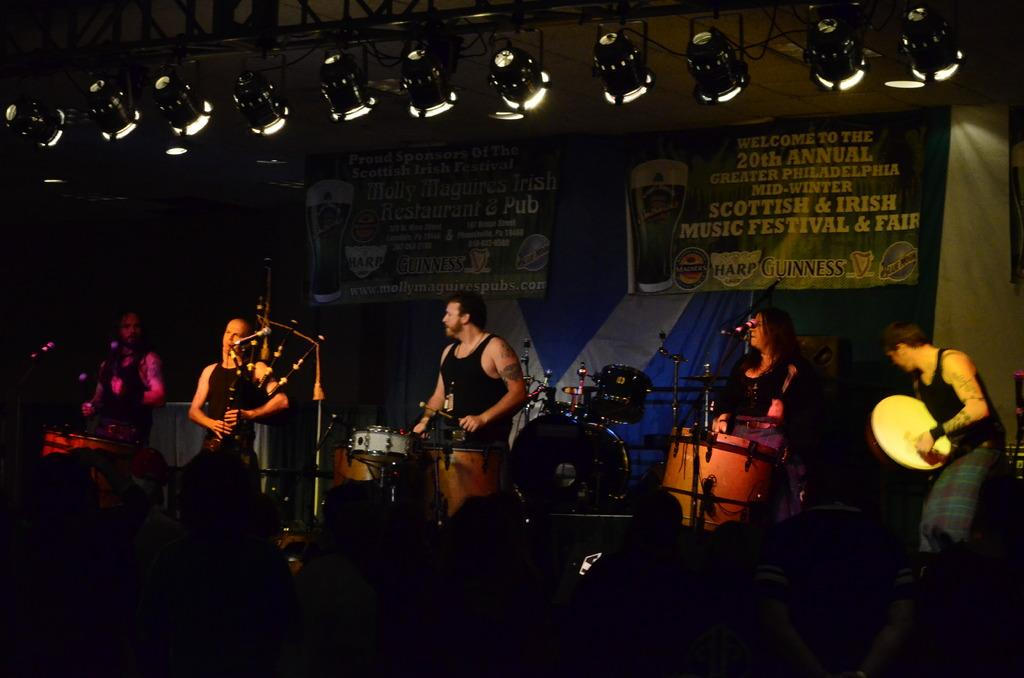What is the woman in the image doing? The woman is playing the bagpipes in the image. Where is the woman located in the image? The woman is on the left side of the image. What is the man in the image doing? The man is beating the drums in the image. Where is the man located in the image? The man is in the middle of the image. What is present on the stage in the image? There are banners on a stage in the image. Where is the stage located in the image? The stage is at the top of the image. What else can be seen in the image? There are lights visible in the image. What type of health advice can be seen on the banners in the image? There is no health advice present on the banners in the image; they are simply decorative elements on the stage. 